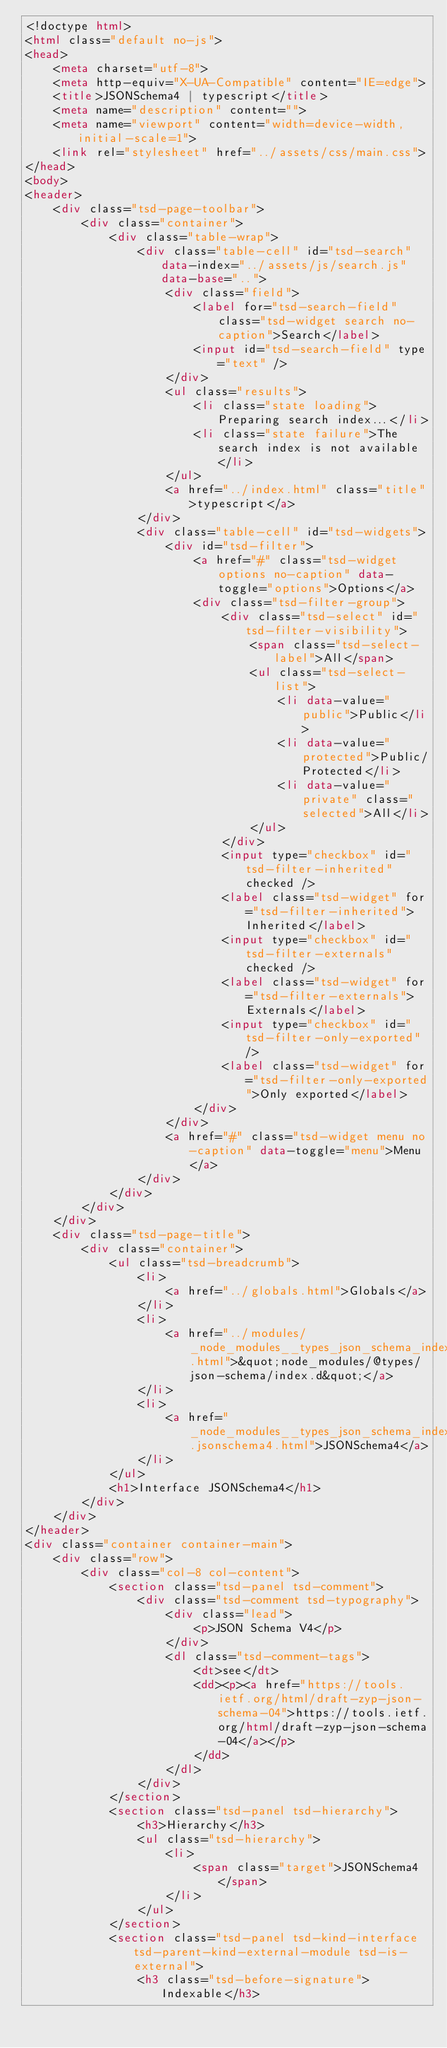Convert code to text. <code><loc_0><loc_0><loc_500><loc_500><_HTML_><!doctype html>
<html class="default no-js">
<head>
	<meta charset="utf-8">
	<meta http-equiv="X-UA-Compatible" content="IE=edge">
	<title>JSONSchema4 | typescript</title>
	<meta name="description" content="">
	<meta name="viewport" content="width=device-width, initial-scale=1">
	<link rel="stylesheet" href="../assets/css/main.css">
</head>
<body>
<header>
	<div class="tsd-page-toolbar">
		<div class="container">
			<div class="table-wrap">
				<div class="table-cell" id="tsd-search" data-index="../assets/js/search.js" data-base="..">
					<div class="field">
						<label for="tsd-search-field" class="tsd-widget search no-caption">Search</label>
						<input id="tsd-search-field" type="text" />
					</div>
					<ul class="results">
						<li class="state loading">Preparing search index...</li>
						<li class="state failure">The search index is not available</li>
					</ul>
					<a href="../index.html" class="title">typescript</a>
				</div>
				<div class="table-cell" id="tsd-widgets">
					<div id="tsd-filter">
						<a href="#" class="tsd-widget options no-caption" data-toggle="options">Options</a>
						<div class="tsd-filter-group">
							<div class="tsd-select" id="tsd-filter-visibility">
								<span class="tsd-select-label">All</span>
								<ul class="tsd-select-list">
									<li data-value="public">Public</li>
									<li data-value="protected">Public/Protected</li>
									<li data-value="private" class="selected">All</li>
								</ul>
							</div>
							<input type="checkbox" id="tsd-filter-inherited" checked />
							<label class="tsd-widget" for="tsd-filter-inherited">Inherited</label>
							<input type="checkbox" id="tsd-filter-externals" checked />
							<label class="tsd-widget" for="tsd-filter-externals">Externals</label>
							<input type="checkbox" id="tsd-filter-only-exported" />
							<label class="tsd-widget" for="tsd-filter-only-exported">Only exported</label>
						</div>
					</div>
					<a href="#" class="tsd-widget menu no-caption" data-toggle="menu">Menu</a>
				</div>
			</div>
		</div>
	</div>
	<div class="tsd-page-title">
		<div class="container">
			<ul class="tsd-breadcrumb">
				<li>
					<a href="../globals.html">Globals</a>
				</li>
				<li>
					<a href="../modules/_node_modules__types_json_schema_index_d_.html">&quot;node_modules/@types/json-schema/index.d&quot;</a>
				</li>
				<li>
					<a href="_node_modules__types_json_schema_index_d_.jsonschema4.html">JSONSchema4</a>
				</li>
			</ul>
			<h1>Interface JSONSchema4</h1>
		</div>
	</div>
</header>
<div class="container container-main">
	<div class="row">
		<div class="col-8 col-content">
			<section class="tsd-panel tsd-comment">
				<div class="tsd-comment tsd-typography">
					<div class="lead">
						<p>JSON Schema V4</p>
					</div>
					<dl class="tsd-comment-tags">
						<dt>see</dt>
						<dd><p><a href="https://tools.ietf.org/html/draft-zyp-json-schema-04">https://tools.ietf.org/html/draft-zyp-json-schema-04</a></p>
						</dd>
					</dl>
				</div>
			</section>
			<section class="tsd-panel tsd-hierarchy">
				<h3>Hierarchy</h3>
				<ul class="tsd-hierarchy">
					<li>
						<span class="target">JSONSchema4</span>
					</li>
				</ul>
			</section>
			<section class="tsd-panel tsd-kind-interface tsd-parent-kind-external-module tsd-is-external">
				<h3 class="tsd-before-signature">Indexable</h3></code> 